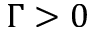<formula> <loc_0><loc_0><loc_500><loc_500>\Gamma > 0</formula> 